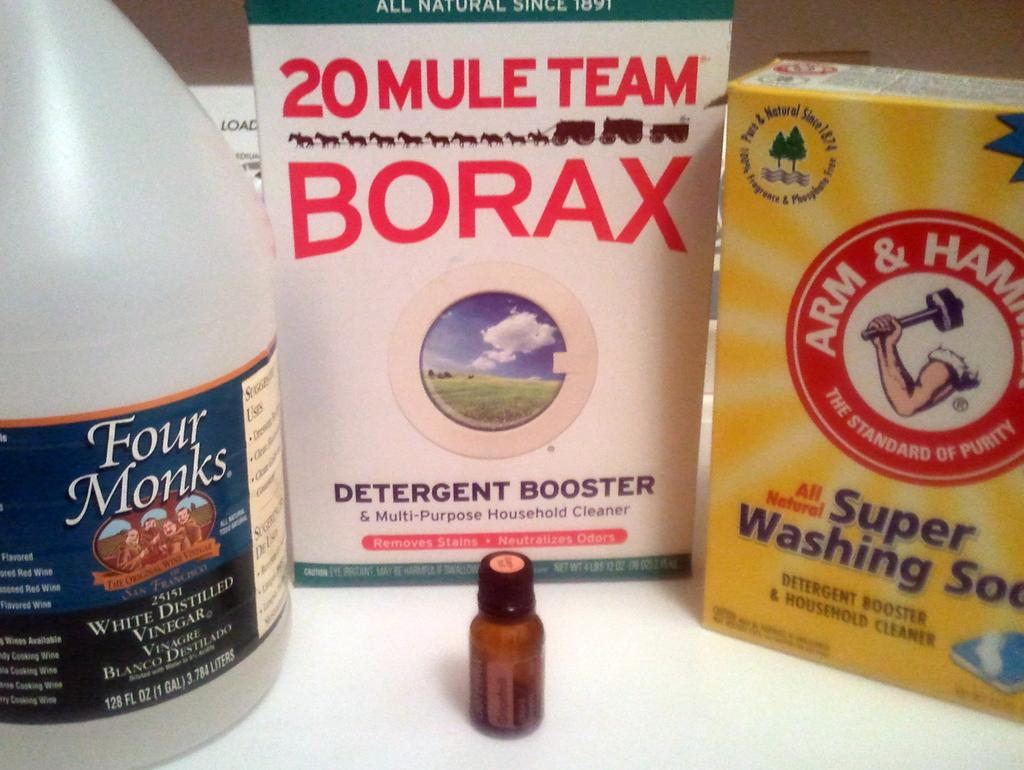How many boxes are on the table in the image? There are two boxes on the table in the image. What other items can be seen on the table? There is a small bottle and a large bottle on the table. Where are the bottles located on the table? The bottles are on the left side of the table. What can be seen in the background of the image? There is a wall in the background of the image. What year is depicted in the image? The image does not depict a specific year; it is a still image of objects on a table. Can you tell me how angry the person in the image is? There is no person present in the image, so it is impossible to determine their level of anger. 